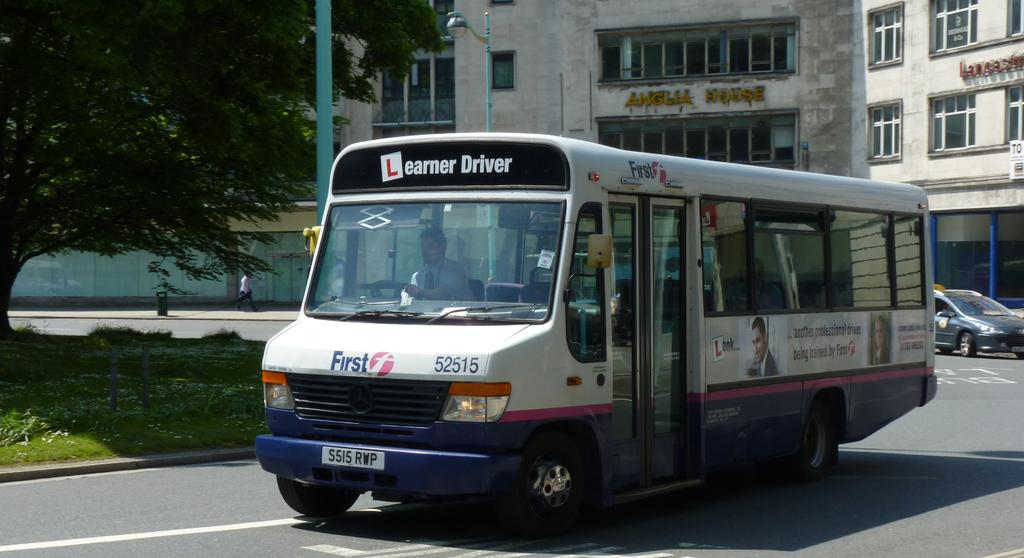What type of motor vehicle is in the image? The type of motor vehicle is not specified, but it is present in the image. Who is inside the motor vehicle? A person is inside the motor vehicle. Where is the motor vehicle located? The motor vehicle is on the road. What can be seen in the background of the image? In the background of the image, there is grass, shrubs, a tree, poles, street lights, buildings, and name boards. Can you recall the memory of the person inside the motor vehicle from the image? The image does not provide any information about the person's memory, so it cannot be determined from the image. Are there any giants visible in the image? There are no giants present in the image. 